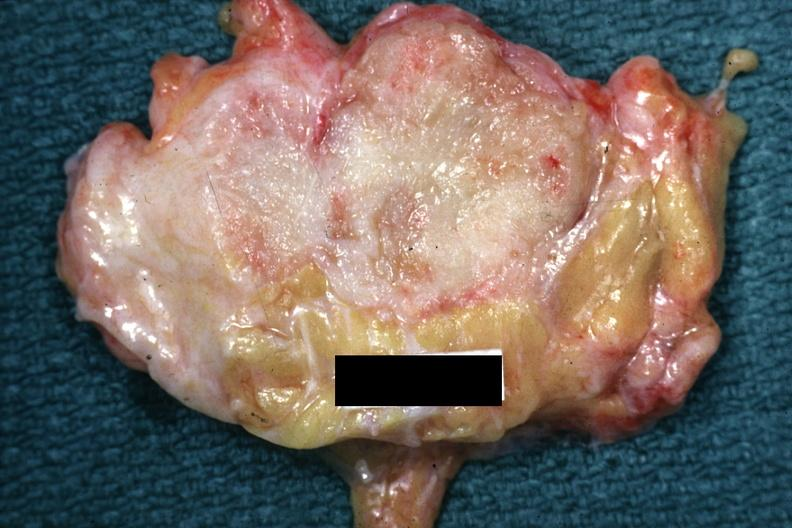does lesion appear too small for this?
Answer the question using a single word or phrase. Yes 